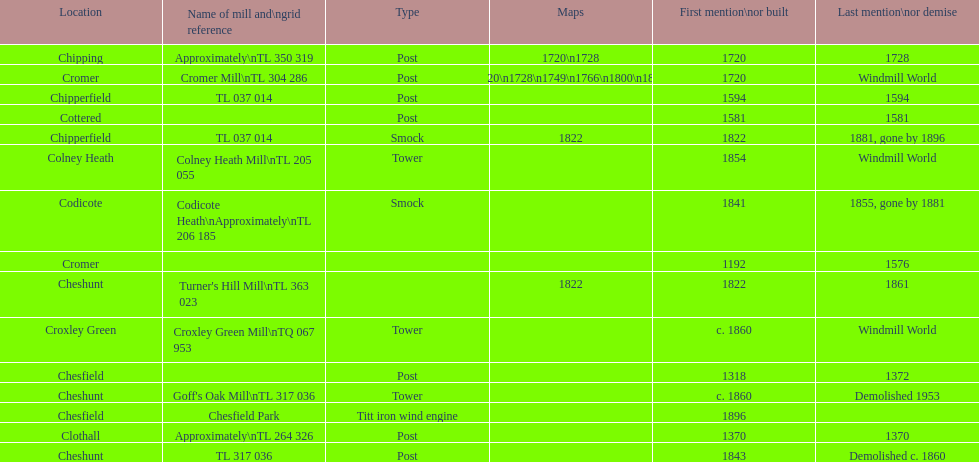How many locations have or had at least 2 windmills? 4. Can you parse all the data within this table? {'header': ['Location', 'Name of mill and\\ngrid reference', 'Type', 'Maps', 'First mention\\nor built', 'Last mention\\nor demise'], 'rows': [['Chipping', 'Approximately\\nTL 350 319', 'Post', '1720\\n1728', '1720', '1728'], ['Cromer', 'Cromer Mill\\nTL 304 286', 'Post', '1720\\n1728\\n1749\\n1766\\n1800\\n1822', '1720', 'Windmill World'], ['Chipperfield', 'TL 037 014', 'Post', '', '1594', '1594'], ['Cottered', '', 'Post', '', '1581', '1581'], ['Chipperfield', 'TL 037 014', 'Smock', '1822', '1822', '1881, gone by 1896'], ['Colney Heath', 'Colney Heath Mill\\nTL 205 055', 'Tower', '', '1854', 'Windmill World'], ['Codicote', 'Codicote Heath\\nApproximately\\nTL 206 185', 'Smock', '', '1841', '1855, gone by 1881'], ['Cromer', '', '', '', '1192', '1576'], ['Cheshunt', "Turner's Hill Mill\\nTL 363 023", '', '1822', '1822', '1861'], ['Croxley Green', 'Croxley Green Mill\\nTQ 067 953', 'Tower', '', 'c. 1860', 'Windmill World'], ['Chesfield', '', 'Post', '', '1318', '1372'], ['Cheshunt', "Goff's Oak Mill\\nTL 317 036", 'Tower', '', 'c. 1860', 'Demolished 1953'], ['Chesfield', 'Chesfield Park', 'Titt iron wind engine', '', '1896', ''], ['Clothall', 'Approximately\\nTL 264 326', 'Post', '', '1370', '1370'], ['Cheshunt', 'TL 317 036', 'Post', '', '1843', 'Demolished c. 1860']]} 